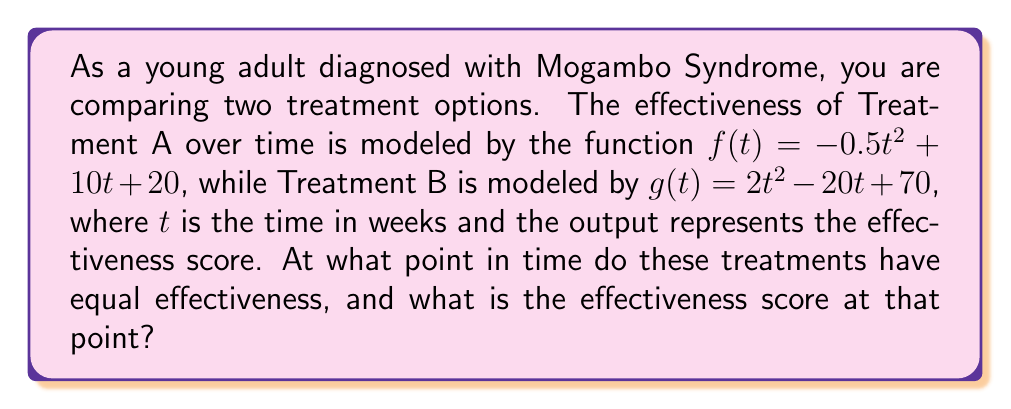Can you answer this question? To find the intersection of the two treatment effectiveness curves, we need to solve the equation $f(t) = g(t)$:

1) Set up the equation:
   $-0.5t^2 + 10t + 20 = 2t^2 - 20t + 70$

2) Rearrange the equation to standard form:
   $-0.5t^2 + 10t + 20 = 2t^2 - 20t + 70$
   $-2.5t^2 + 30t - 50 = 0$

3) Multiply all terms by -2 to simplify the leading coefficient:
   $5t^2 - 60t + 100 = 0$

4) This is a quadratic equation. We can solve it using the quadratic formula:
   $t = \frac{-b \pm \sqrt{b^2 - 4ac}}{2a}$

   Where $a = 5$, $b = -60$, and $c = 100$

5) Substituting these values:
   $t = \frac{60 \pm \sqrt{(-60)^2 - 4(5)(100)}}{2(5)}$
   $t = \frac{60 \pm \sqrt{3600 - 2000}}{10}$
   $t = \frac{60 \pm \sqrt{1600}}{10}$
   $t = \frac{60 \pm 40}{10}$

6) This gives us two solutions:
   $t_1 = \frac{60 + 40}{10} = 10$
   $t_2 = \frac{60 - 40}{10} = 2$

7) To find the effectiveness score at these points, we can substitute either $t$ value into either function. Let's use $f(t)$ and $t = 10$:

   $f(10) = -0.5(10)^2 + 10(10) + 20$
   $f(10) = -50 + 100 + 20 = 70$

Therefore, the treatments have equal effectiveness at 2 weeks and 10 weeks, with an effectiveness score of 70.
Answer: The treatments have equal effectiveness at $t = 2$ weeks and $t = 10$ weeks, with an effectiveness score of 70. 